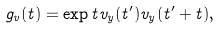<formula> <loc_0><loc_0><loc_500><loc_500>g _ { v } ( t ) = \exp t { v _ { y } ( t ^ { \prime } ) v _ { y } ( t ^ { \prime } + t ) } ,</formula> 